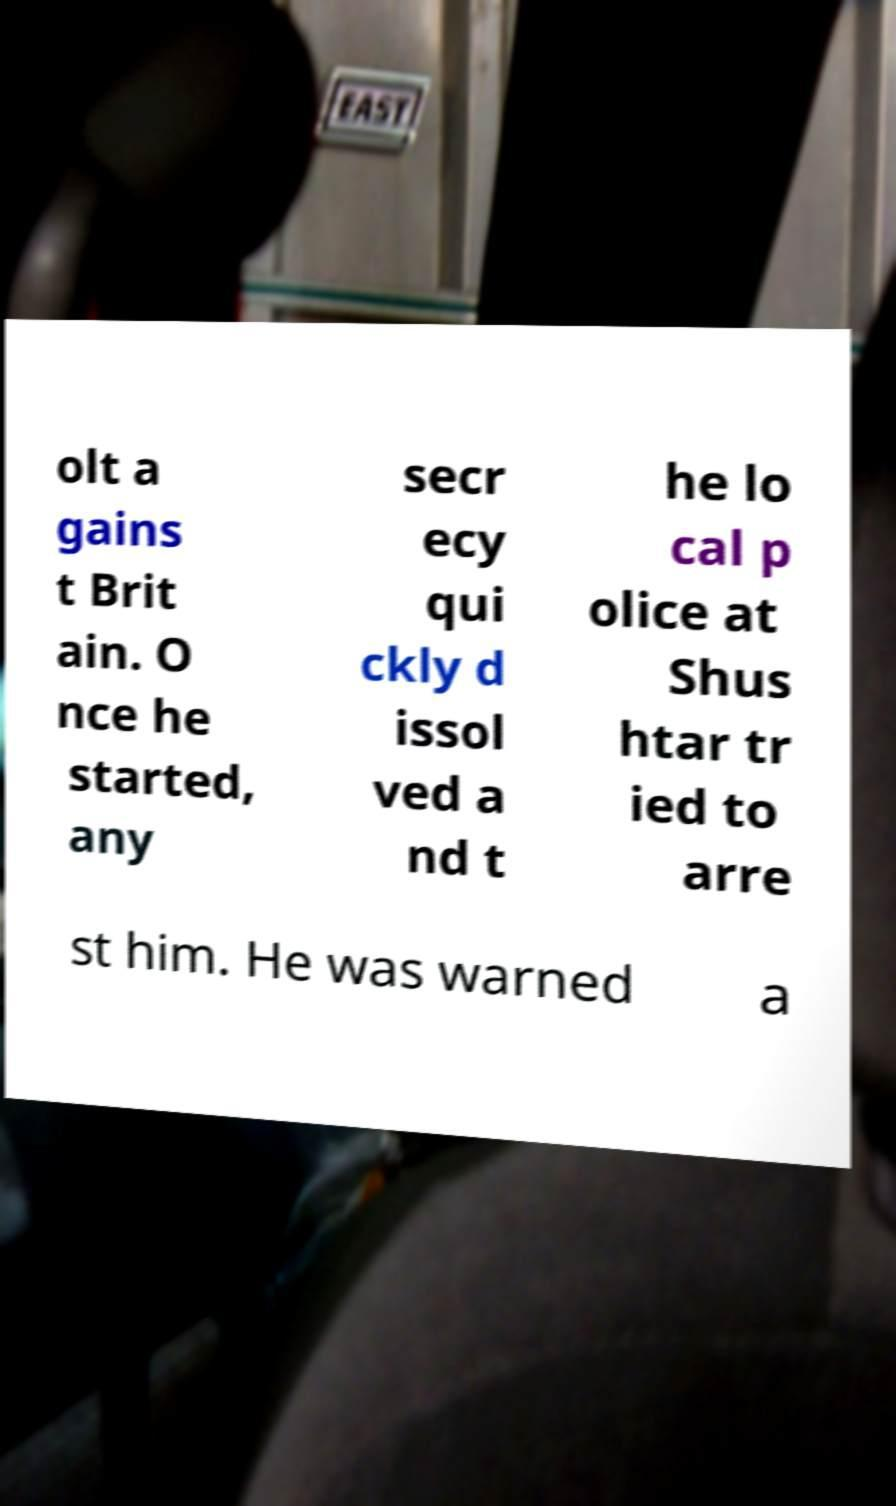Please identify and transcribe the text found in this image. olt a gains t Brit ain. O nce he started, any secr ecy qui ckly d issol ved a nd t he lo cal p olice at Shus htar tr ied to arre st him. He was warned a 